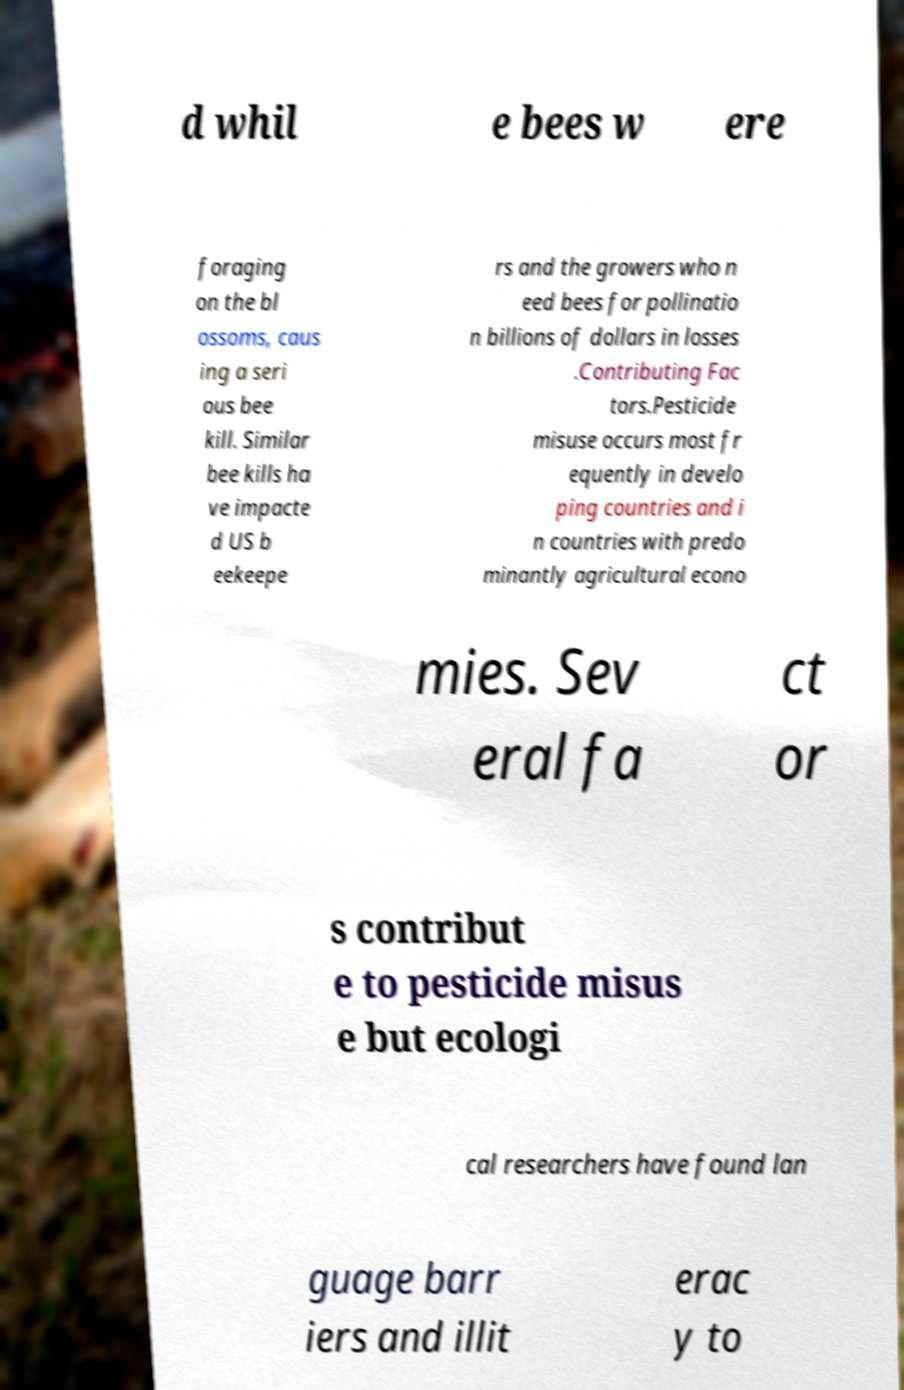There's text embedded in this image that I need extracted. Can you transcribe it verbatim? d whil e bees w ere foraging on the bl ossoms, caus ing a seri ous bee kill. Similar bee kills ha ve impacte d US b eekeepe rs and the growers who n eed bees for pollinatio n billions of dollars in losses .Contributing Fac tors.Pesticide misuse occurs most fr equently in develo ping countries and i n countries with predo minantly agricultural econo mies. Sev eral fa ct or s contribut e to pesticide misus e but ecologi cal researchers have found lan guage barr iers and illit erac y to 